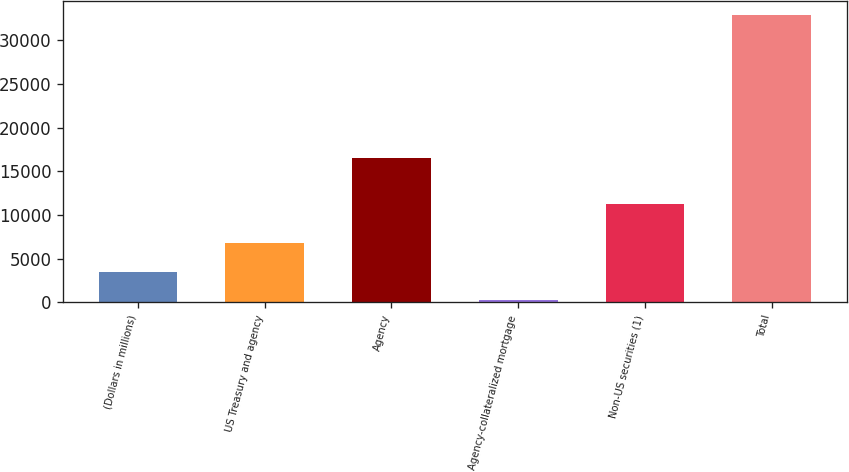<chart> <loc_0><loc_0><loc_500><loc_500><bar_chart><fcel>(Dollars in millions)<fcel>US Treasury and agency<fcel>Agency<fcel>Agency-collateralized mortgage<fcel>Non-US securities (1)<fcel>Total<nl><fcel>3480.6<fcel>6743.2<fcel>16500<fcel>218<fcel>11315<fcel>32844<nl></chart> 